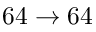<formula> <loc_0><loc_0><loc_500><loc_500>6 4 \rightarrow 6 4</formula> 